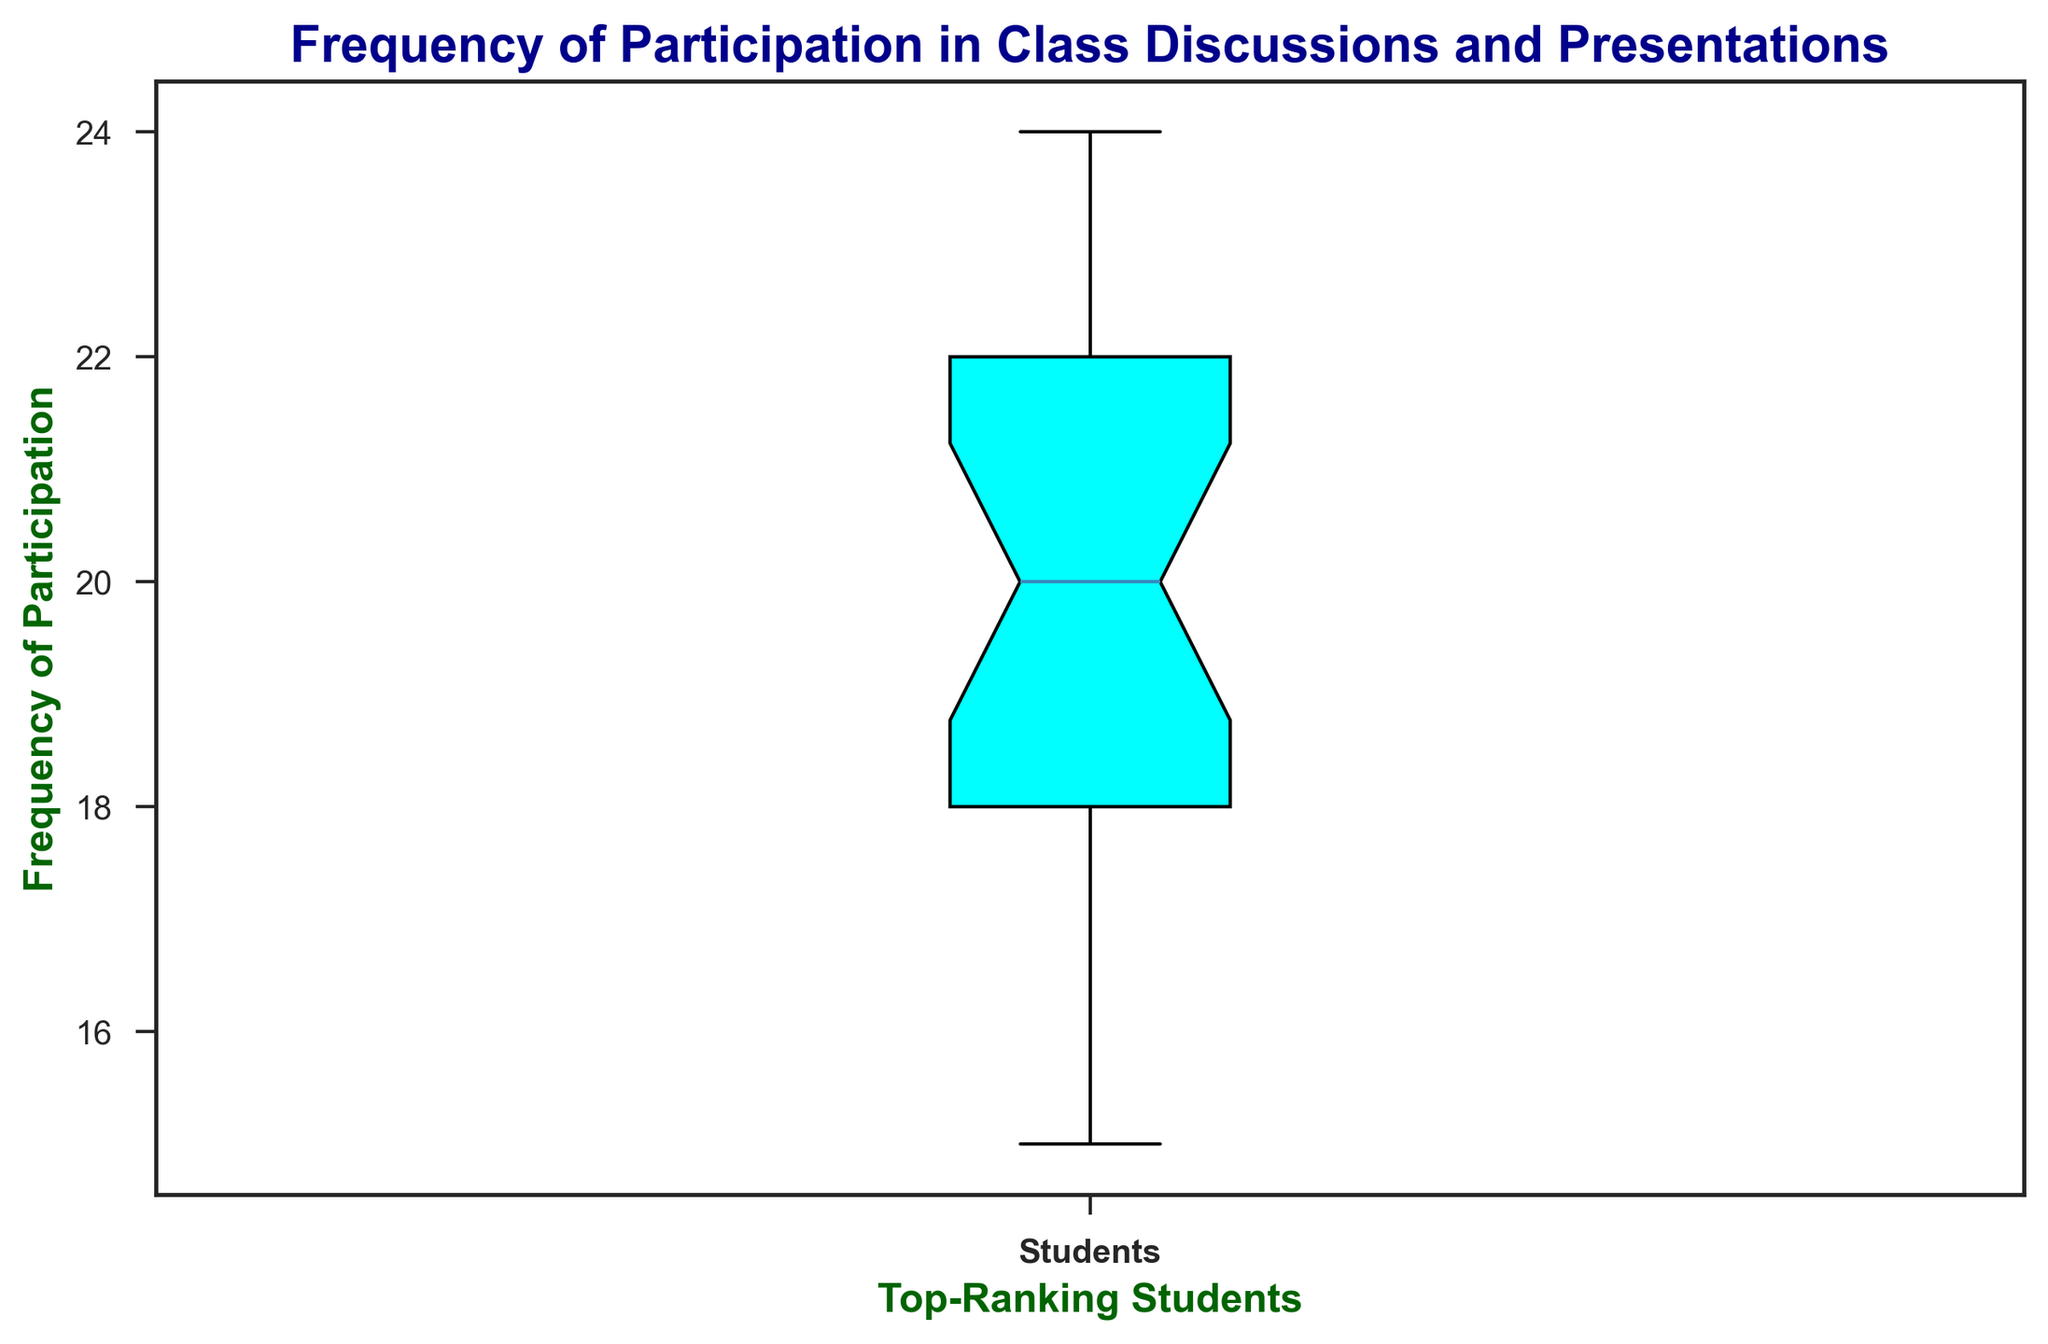What is the median frequency of participation among top-ranking students? The median is the middle value when the data is arranged in ascending order. The sorted data is [15, 16, 17, 17, 18, 18, 18, 18, 19, 19, 19, 20, 20, 20, 20, 21, 21, 21, 22, 22, 22, 23, 23, 23, 24, 24]. There are 26 values, so the median is the average of the 13th and 14th values, which are both 20.
Answer: 20 What is the range of the frequency of participation? The range is the difference between the maximum and minimum values. The minimum value is 15 and the maximum value is 24. So, the range is 24 - 15.
Answer: 9 What are the lower and upper quartiles of the frequency of participation? The lower quartile (Q1) is the median of the first half of the data, and the upper quartile (Q3) is the median of the second half. For Q1, the first half is [15, 16, 17, 17, 18, 18, 18, 18, 19, 19, 19, 20, 20], and Q1 is the median of this set, which is 18. For Q3, the second half is [20, 20, 21, 21, 21, 22, 22, 22, 23, 23, 23, 24, 24], and Q3 is the median of this set, which is 22.
Answer: 18 and 22 What is the interquartile range (IQR) of the frequency of participation? The IQR is the difference between the upper quartile (Q3) and the lower quartile (Q1). From the previous question, Q3 is 22 and Q1 is 18. So, the IQR is 22 - 18.
Answer: 4 Which students have the highest frequency of participation and what is that frequency? The highest frequency of participation is indicated by the top whisker or outlier dots of the box plot. Based on the given data, the maximum value is 24. Students H and S have this frequency.
Answer: Students H and S, 24 Are there any outliers in the frequency of participation data? Outliers are usually represented as points outside the whiskers in a box plot. By checking the range and quartiles, the absence of very distant points suggests no extreme outliers.
Answer: No What color represents the box for the frequency distribution in the plot? The box in the box plot is shaded with a specific color. In the code, various colors such as cyan, light blue, light green, tan, and light pink are used.
Answer: Cyan Which students have the lowest frequency of participation and what is that frequency? The lowest frequency of participation is indicated by the bottom whisker or outlier dots of the box plot. According to the given data, the minimum value is 15. Student A has this frequency.
Answer: Student A, 15 